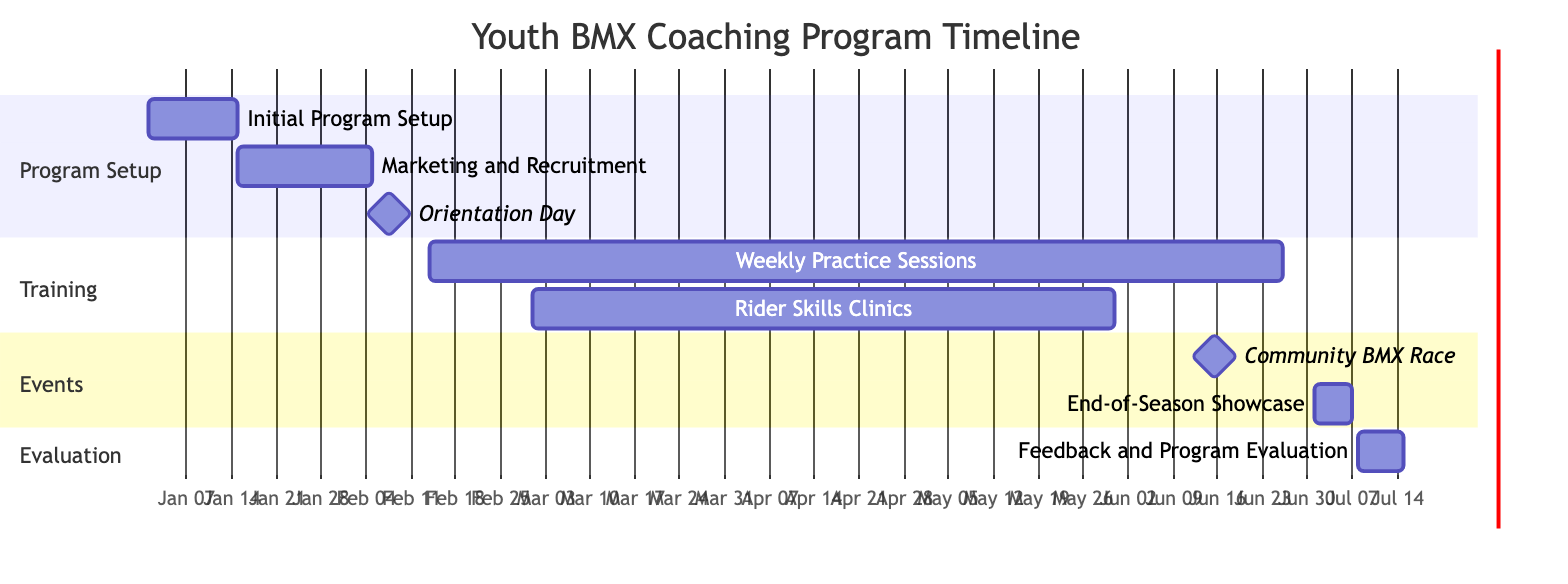What is the duration of the "Initial Program Setup"? The "Initial Program Setup" starts on January 1, 2024, and ends on January 15, 2024. Calculating the number of days between these two dates gives us a duration of 15 days.
Answer: 15 days How many Weekly Practice Sessions are scheduled? The "Weekly Practice Sessions" start on February 14, 2024, and end on June 26, 2024. The sessions happen weekly for this time frame. Counting the weeks between the start and end dates gives us a total of 19 sessions.
Answer: 19 sessions What day is the Orientation Day scheduled? The "Orientation Day" is marked as a milestone in the diagram, scheduled for February 7, 2024, with the date clearly indicated.
Answer: February 7, 2024 What are the start and end dates of the Rider Skills Clinics? The "Rider Skills Clinics" begin on March 1, 2024, and conclude on May 31, 2024, as shown in the diagram under the training section.
Answer: March 1, 2024 to May 31, 2024 How does the "Community BMX Race" relate time-wise to the "End-of-Season Showcase"? The "Community BMX Race" occurs on June 15, 2024, while the "End-of-Season Showcase" starts on July 1, 2024. This means there's a gap of 16 days between the two events.
Answer: 16 days What is the last activity in the diagram? The last activity listed in the diagram is "Feedback and Program Evaluation," which runs from July 8, 2024, to July 15, 2024. It is the final step in the timeline, occurring after the showcase.
Answer: Feedback and Program Evaluation Which section contains the "Weekly Practice Sessions"? The "Weekly Practice Sessions" are located in the "Training" section of the diagram. This section encompasses all activities related to the training of young riders.
Answer: Training Which month follows the "Marketing and Recruitment" phase? The "Marketing and Recruitment" phase ends on February 5, 2024. The next phase, "Orientation Day," occurs on February 7, 2024; hence, February follows this phase.
Answer: February 